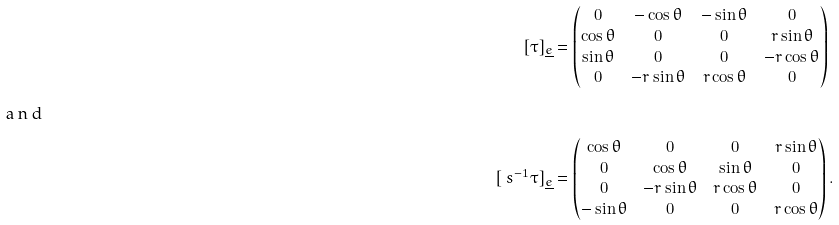<formula> <loc_0><loc_0><loc_500><loc_500>[ \tau ] _ { \underline { e } } & = \begin{pmatrix} 0 & - \cos \theta & - \sin \theta & 0 \\ \cos \theta & 0 & 0 & r \sin \theta \\ \sin \theta & 0 & 0 & - r \cos \theta \\ 0 & - r \sin \theta & r \cos \theta & 0 \end{pmatrix} \\ \intertext { a n d } [ \ s ^ { - 1 } \tau ] _ { \underline { e } } & = \begin{pmatrix} \cos \theta & 0 & 0 & r \sin \theta \\ 0 & \cos \theta & \sin \theta & 0 \\ 0 & - r \sin \theta & r \cos \theta & 0 \\ - \sin \theta & 0 & 0 & r \cos \theta \end{pmatrix} .</formula> 